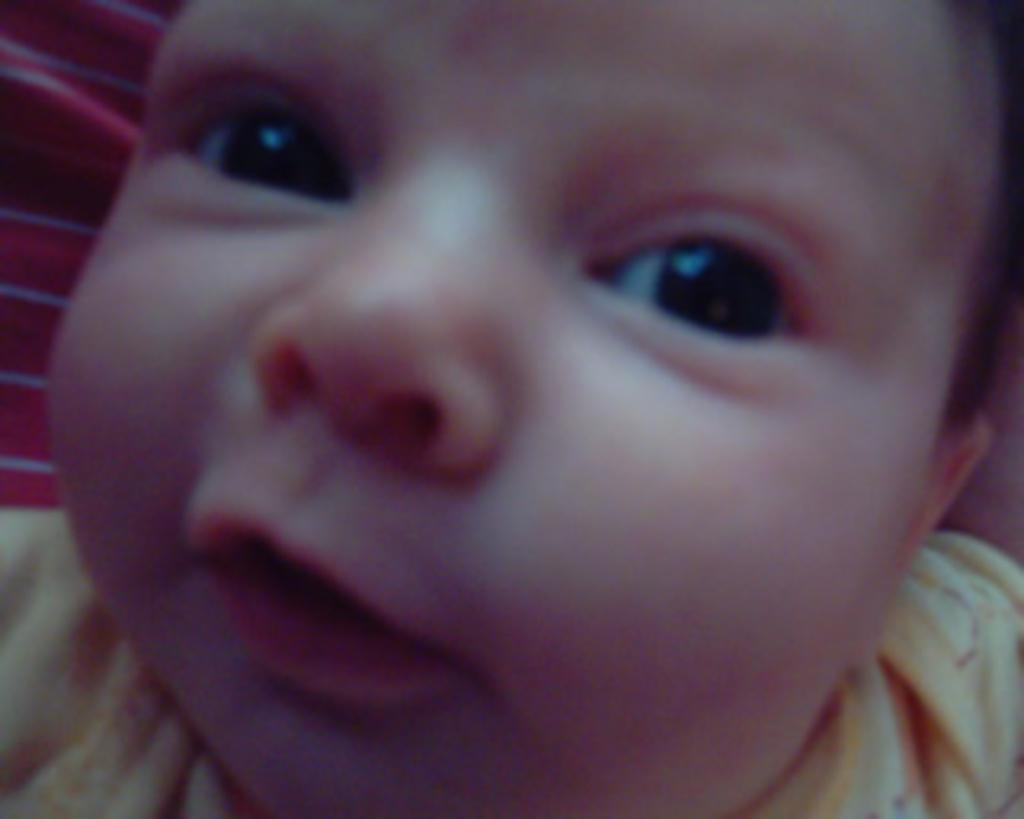What is the main subject of the image? The main subject of the image is a kid. What is the kid wearing in the image? The kid is wearing a yellow dress in the image. What grade does the kid hate in the image? There is no indication of the kid's grade or any feelings towards a grade in the image. 